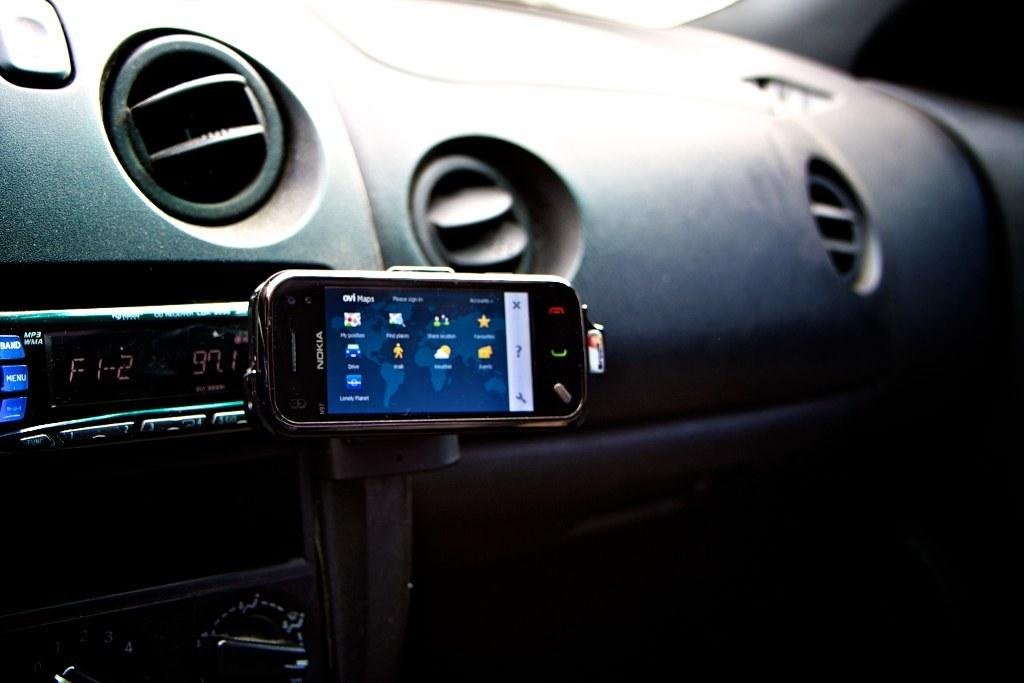What is the color of the car's dashboard in the image? The dashboard of the car is black in color. What other black object can be seen on the dashboard? There is a mobile on the dashboard, and it is also black in color. What device is visible in the image that is used for playing music or other audio? The sound system is visible in the image. What type of controls are present on the dashboard for the driver to interact with? There are buttons present on the dashboard. What type of scent can be detected coming from the cherries in the image? There are no cherries present in the image, so it is not possible to detect any scent from them. 